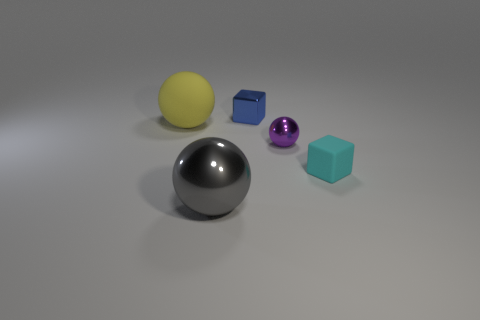There is another object that is the same shape as the tiny cyan rubber thing; what is its color?
Make the answer very short. Blue. There is a large thing in front of the yellow rubber object in front of the blue metallic object; what number of large shiny spheres are behind it?
Make the answer very short. 0. Are there any other things that are the same material as the yellow ball?
Your answer should be compact. Yes. Are there fewer cyan matte blocks that are on the right side of the large yellow rubber thing than large cyan spheres?
Make the answer very short. No. What is the size of the purple metal object that is the same shape as the big matte object?
Your response must be concise. Small. What number of big spheres are the same material as the gray object?
Your answer should be compact. 0. Are the ball in front of the tiny purple shiny thing and the cyan block made of the same material?
Your answer should be very brief. No. Are there an equal number of gray metal spheres that are behind the small blue cube and small cyan blocks?
Ensure brevity in your answer.  No. The blue metallic thing has what size?
Make the answer very short. Small. What number of metal cubes have the same color as the small matte cube?
Give a very brief answer. 0. 